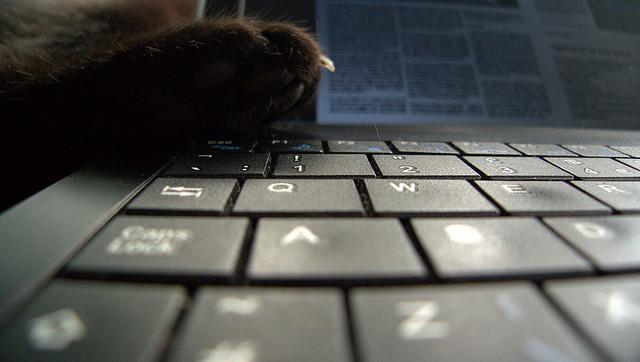Is the cat typing on the computer?
Be succinct. No. What color is the computer?
Concise answer only. Black. What color is the keyboard?
Be succinct. Black. Where is the arrow?
Short answer required. Under paw. 